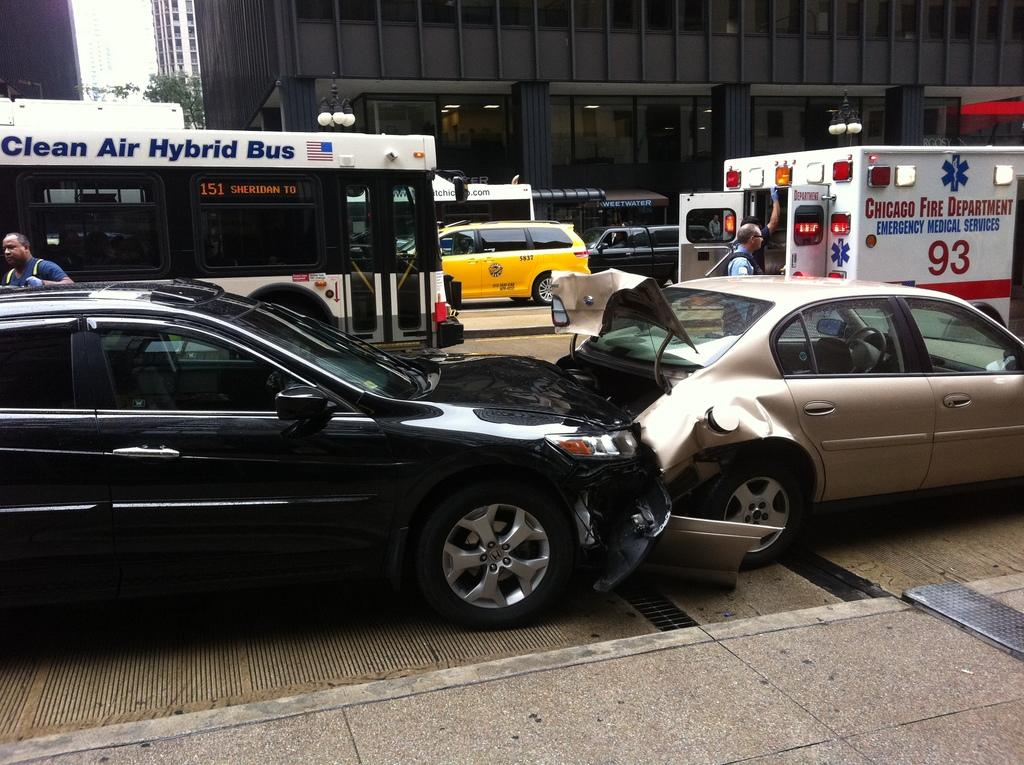<image>
Share a concise interpretation of the image provided. At the scene of a car accident is an ambulance and a clean air hybrid bus 